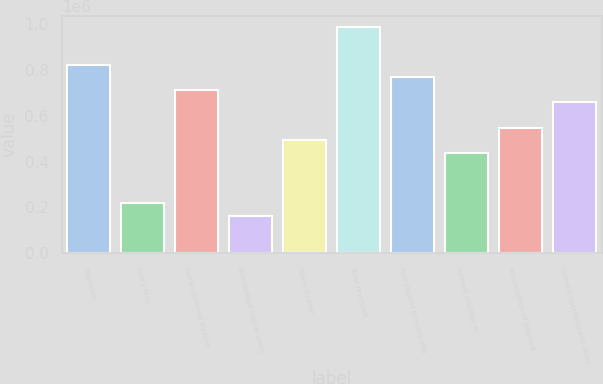Convert chart to OTSL. <chart><loc_0><loc_0><loc_500><loc_500><bar_chart><fcel>Premiums<fcel>Policy fees<fcel>Net investment income<fcel>Net realized capital gains<fcel>Other income<fcel>Total revenues<fcel>Policyholder benefits and<fcel>Interest credited to<fcel>Amortization of deferred<fcel>General operating and other<nl><fcel>822949<fcel>219454<fcel>713222<fcel>164591<fcel>493770<fcel>987538<fcel>768085<fcel>438907<fcel>548633<fcel>658359<nl></chart> 